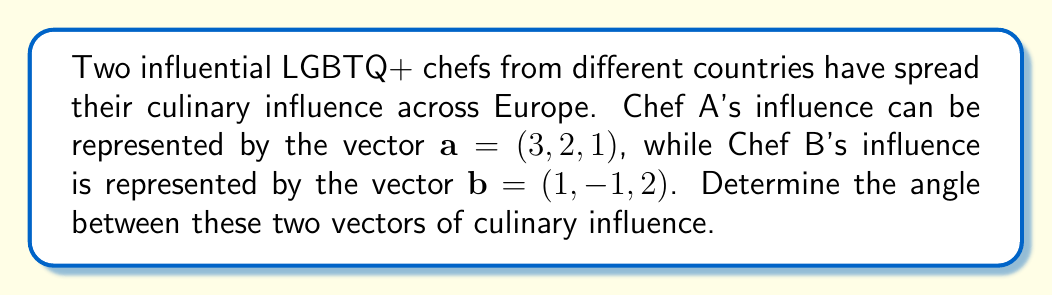What is the answer to this math problem? To find the angle between two vectors, we can use the dot product formula:

$$\cos \theta = \frac{\mathbf{a} \cdot \mathbf{b}}{|\mathbf{a}||\mathbf{b}|}$$

Step 1: Calculate the dot product $\mathbf{a} \cdot \mathbf{b}$
$$\mathbf{a} \cdot \mathbf{b} = (3)(1) + (2)(-1) + (1)(2) = 3 - 2 + 2 = 3$$

Step 2: Calculate the magnitudes of vectors $\mathbf{a}$ and $\mathbf{b}$
$$|\mathbf{a}| = \sqrt{3^2 + 2^2 + 1^2} = \sqrt{14}$$
$$|\mathbf{b}| = \sqrt{1^2 + (-1)^2 + 2^2} = \sqrt{6}$$

Step 3: Substitute into the formula
$$\cos \theta = \frac{3}{\sqrt{14}\sqrt{6}}$$

Step 4: Simplify
$$\cos \theta = \frac{3}{\sqrt{84}}$$

Step 5: Take the inverse cosine (arccos) of both sides
$$\theta = \arccos\left(\frac{3}{\sqrt{84}}\right)$$

Step 6: Calculate the result (approximately)
$$\theta \approx 1.249 \text{ radians} \approx 71.57\text{°}$$
Answer: $\arccos\left(\frac{3}{\sqrt{84}}\right) \approx 71.57\text{°}$ 